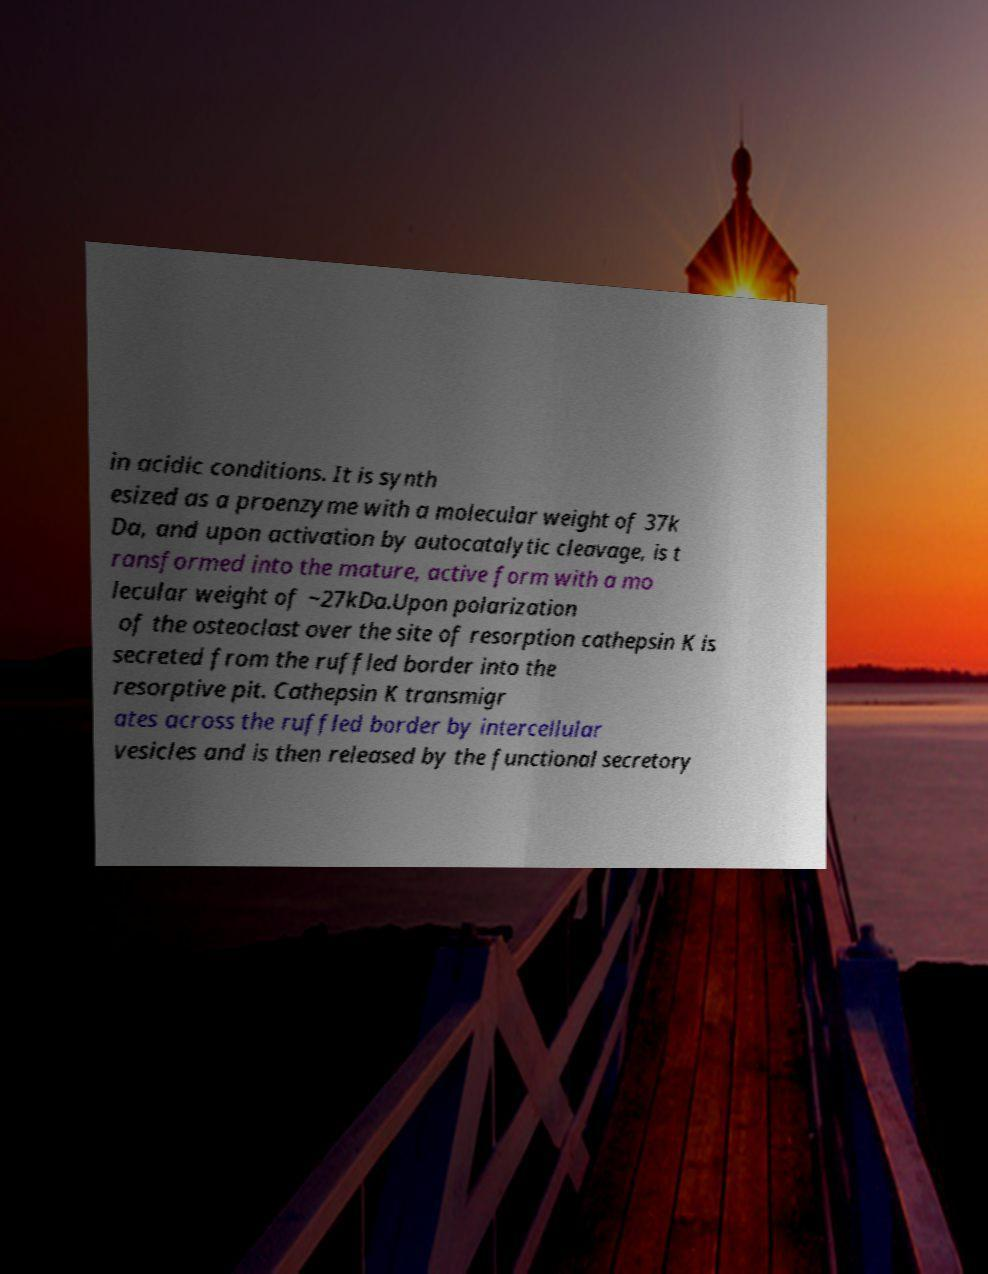Please read and relay the text visible in this image. What does it say? in acidic conditions. It is synth esized as a proenzyme with a molecular weight of 37k Da, and upon activation by autocatalytic cleavage, is t ransformed into the mature, active form with a mo lecular weight of ~27kDa.Upon polarization of the osteoclast over the site of resorption cathepsin K is secreted from the ruffled border into the resorptive pit. Cathepsin K transmigr ates across the ruffled border by intercellular vesicles and is then released by the functional secretory 